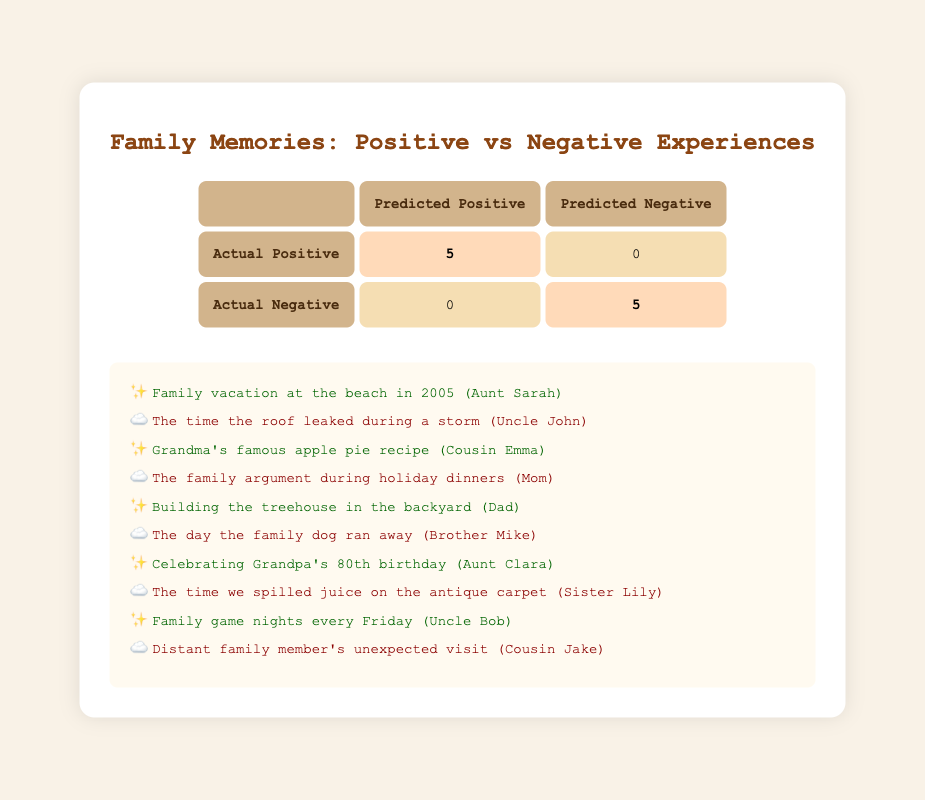What is the total number of positive experiences shared? By looking at the table, we can see that there are 5 actual positive experiences, as indicated in the row for "Actual Positive" where it shows "5" under "Predicted Positive."
Answer: 5 How many negative experiences are predicted? The table indicates that there are 5 actual negative experiences since the "Actual Negative" row shows "5" under "Predicted Negative."
Answer: 5 Is there any story that was incorrectly predicted as positive? No, the table shows that all actual negative experiences have been accurately predicted as negative since there are "0" in the "Predicted Positive" column under "Actual Negative."
Answer: No What is the total number of stories shared? The total number of stories is the sum of positive and negative experiences. Since there are 5 positive and 5 negative stories, the total is 5 + 5 = 10.
Answer: 10 How many stories were shared that were about experiences? The table focuses on experiences categorized as either positive or negative, and since every story shared falls into these categories, the total is again 10.
Answer: 10 What is the ratio of positive experiences to negative experiences? There are 5 positive experiences and 5 negative experiences. The ratio is 5:5, which can be simplified to 1:1.
Answer: 1:1 How many family members shared positive stories? The positive stories are shared by Aunt Sarah, Cousin Emma, Dad, Aunt Clara, and Uncle Bob, making a total of 5 family members sharing positive experiences.
Answer: 5 Was there any instance where a negative experience received a positive prediction? No, the observation shows that all negative experiences were correctly categorized with "0" shown in the "Predicted Positive" column for actual negatives.
Answer: No What can you infer about the family memories based on this table? The table reflects a balanced view of family memories with equal distribution between positive and negative experiences, indicating a variety of shared family moments.
Answer: Balanced distribution of memories 